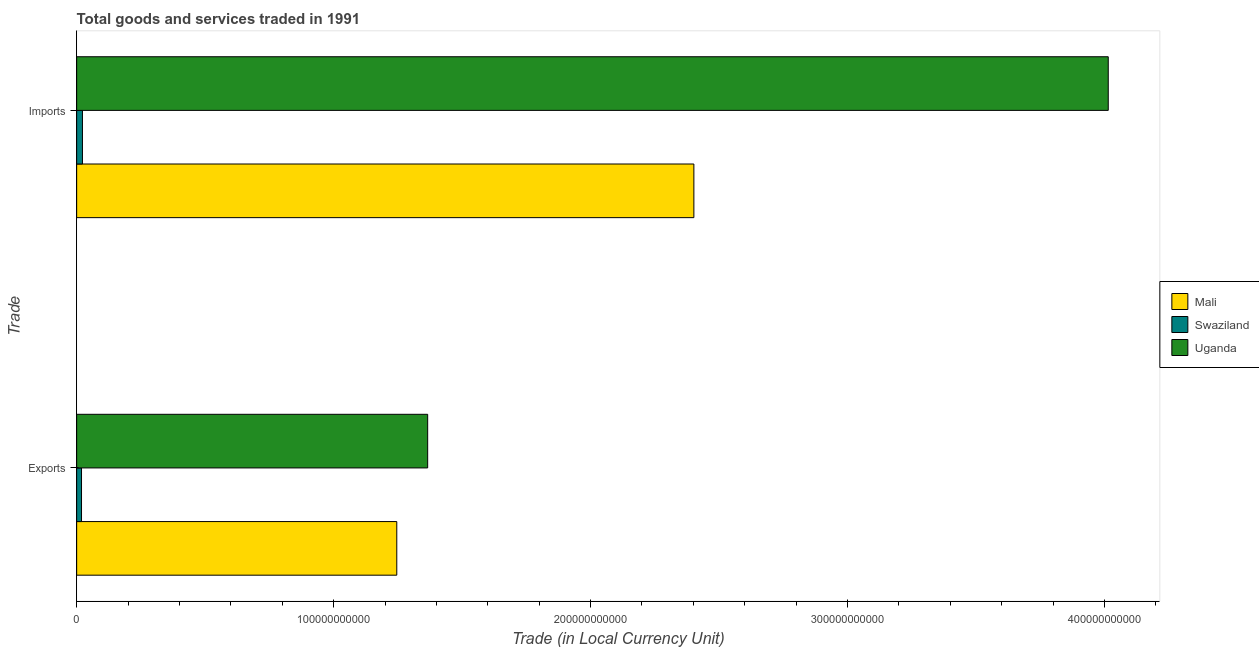Are the number of bars on each tick of the Y-axis equal?
Offer a terse response. Yes. How many bars are there on the 2nd tick from the top?
Provide a succinct answer. 3. What is the label of the 2nd group of bars from the top?
Give a very brief answer. Exports. What is the imports of goods and services in Mali?
Offer a very short reply. 2.40e+11. Across all countries, what is the maximum imports of goods and services?
Offer a very short reply. 4.01e+11. Across all countries, what is the minimum imports of goods and services?
Offer a very short reply. 2.26e+09. In which country was the export of goods and services maximum?
Ensure brevity in your answer.  Uganda. In which country was the export of goods and services minimum?
Offer a terse response. Swaziland. What is the total export of goods and services in the graph?
Provide a short and direct response. 2.63e+11. What is the difference between the imports of goods and services in Uganda and that in Mali?
Keep it short and to the point. 1.61e+11. What is the difference between the imports of goods and services in Swaziland and the export of goods and services in Mali?
Your answer should be compact. -1.22e+11. What is the average imports of goods and services per country?
Keep it short and to the point. 2.15e+11. What is the difference between the imports of goods and services and export of goods and services in Uganda?
Provide a succinct answer. 2.65e+11. In how many countries, is the export of goods and services greater than 220000000000 LCU?
Make the answer very short. 0. What is the ratio of the imports of goods and services in Uganda to that in Mali?
Your answer should be very brief. 1.67. In how many countries, is the imports of goods and services greater than the average imports of goods and services taken over all countries?
Your answer should be compact. 2. What does the 3rd bar from the top in Exports represents?
Ensure brevity in your answer.  Mali. What does the 1st bar from the bottom in Exports represents?
Give a very brief answer. Mali. How many countries are there in the graph?
Provide a succinct answer. 3. What is the difference between two consecutive major ticks on the X-axis?
Make the answer very short. 1.00e+11. Does the graph contain grids?
Offer a terse response. No. Where does the legend appear in the graph?
Your response must be concise. Center right. How are the legend labels stacked?
Make the answer very short. Vertical. What is the title of the graph?
Provide a succinct answer. Total goods and services traded in 1991. Does "Sao Tome and Principe" appear as one of the legend labels in the graph?
Offer a terse response. No. What is the label or title of the X-axis?
Offer a very short reply. Trade (in Local Currency Unit). What is the label or title of the Y-axis?
Keep it short and to the point. Trade. What is the Trade (in Local Currency Unit) of Mali in Exports?
Make the answer very short. 1.25e+11. What is the Trade (in Local Currency Unit) of Swaziland in Exports?
Keep it short and to the point. 1.89e+09. What is the Trade (in Local Currency Unit) of Uganda in Exports?
Your answer should be compact. 1.37e+11. What is the Trade (in Local Currency Unit) of Mali in Imports?
Keep it short and to the point. 2.40e+11. What is the Trade (in Local Currency Unit) in Swaziland in Imports?
Provide a short and direct response. 2.26e+09. What is the Trade (in Local Currency Unit) in Uganda in Imports?
Your answer should be compact. 4.01e+11. Across all Trade, what is the maximum Trade (in Local Currency Unit) of Mali?
Give a very brief answer. 2.40e+11. Across all Trade, what is the maximum Trade (in Local Currency Unit) in Swaziland?
Provide a short and direct response. 2.26e+09. Across all Trade, what is the maximum Trade (in Local Currency Unit) in Uganda?
Keep it short and to the point. 4.01e+11. Across all Trade, what is the minimum Trade (in Local Currency Unit) in Mali?
Offer a very short reply. 1.25e+11. Across all Trade, what is the minimum Trade (in Local Currency Unit) in Swaziland?
Provide a succinct answer. 1.89e+09. Across all Trade, what is the minimum Trade (in Local Currency Unit) in Uganda?
Your answer should be compact. 1.37e+11. What is the total Trade (in Local Currency Unit) of Mali in the graph?
Make the answer very short. 3.65e+11. What is the total Trade (in Local Currency Unit) in Swaziland in the graph?
Provide a short and direct response. 4.15e+09. What is the total Trade (in Local Currency Unit) of Uganda in the graph?
Keep it short and to the point. 5.38e+11. What is the difference between the Trade (in Local Currency Unit) of Mali in Exports and that in Imports?
Your response must be concise. -1.16e+11. What is the difference between the Trade (in Local Currency Unit) of Swaziland in Exports and that in Imports?
Your answer should be very brief. -3.63e+08. What is the difference between the Trade (in Local Currency Unit) of Uganda in Exports and that in Imports?
Make the answer very short. -2.65e+11. What is the difference between the Trade (in Local Currency Unit) in Mali in Exports and the Trade (in Local Currency Unit) in Swaziland in Imports?
Provide a succinct answer. 1.22e+11. What is the difference between the Trade (in Local Currency Unit) in Mali in Exports and the Trade (in Local Currency Unit) in Uganda in Imports?
Provide a succinct answer. -2.77e+11. What is the difference between the Trade (in Local Currency Unit) of Swaziland in Exports and the Trade (in Local Currency Unit) of Uganda in Imports?
Ensure brevity in your answer.  -4.00e+11. What is the average Trade (in Local Currency Unit) in Mali per Trade?
Ensure brevity in your answer.  1.82e+11. What is the average Trade (in Local Currency Unit) of Swaziland per Trade?
Keep it short and to the point. 2.07e+09. What is the average Trade (in Local Currency Unit) of Uganda per Trade?
Offer a very short reply. 2.69e+11. What is the difference between the Trade (in Local Currency Unit) of Mali and Trade (in Local Currency Unit) of Swaziland in Exports?
Ensure brevity in your answer.  1.23e+11. What is the difference between the Trade (in Local Currency Unit) of Mali and Trade (in Local Currency Unit) of Uganda in Exports?
Keep it short and to the point. -1.20e+1. What is the difference between the Trade (in Local Currency Unit) in Swaziland and Trade (in Local Currency Unit) in Uganda in Exports?
Offer a very short reply. -1.35e+11. What is the difference between the Trade (in Local Currency Unit) of Mali and Trade (in Local Currency Unit) of Swaziland in Imports?
Your answer should be compact. 2.38e+11. What is the difference between the Trade (in Local Currency Unit) of Mali and Trade (in Local Currency Unit) of Uganda in Imports?
Ensure brevity in your answer.  -1.61e+11. What is the difference between the Trade (in Local Currency Unit) in Swaziland and Trade (in Local Currency Unit) in Uganda in Imports?
Offer a very short reply. -3.99e+11. What is the ratio of the Trade (in Local Currency Unit) in Mali in Exports to that in Imports?
Make the answer very short. 0.52. What is the ratio of the Trade (in Local Currency Unit) in Swaziland in Exports to that in Imports?
Ensure brevity in your answer.  0.84. What is the ratio of the Trade (in Local Currency Unit) in Uganda in Exports to that in Imports?
Keep it short and to the point. 0.34. What is the difference between the highest and the second highest Trade (in Local Currency Unit) in Mali?
Your response must be concise. 1.16e+11. What is the difference between the highest and the second highest Trade (in Local Currency Unit) of Swaziland?
Give a very brief answer. 3.63e+08. What is the difference between the highest and the second highest Trade (in Local Currency Unit) in Uganda?
Offer a terse response. 2.65e+11. What is the difference between the highest and the lowest Trade (in Local Currency Unit) of Mali?
Your response must be concise. 1.16e+11. What is the difference between the highest and the lowest Trade (in Local Currency Unit) of Swaziland?
Make the answer very short. 3.63e+08. What is the difference between the highest and the lowest Trade (in Local Currency Unit) in Uganda?
Offer a terse response. 2.65e+11. 